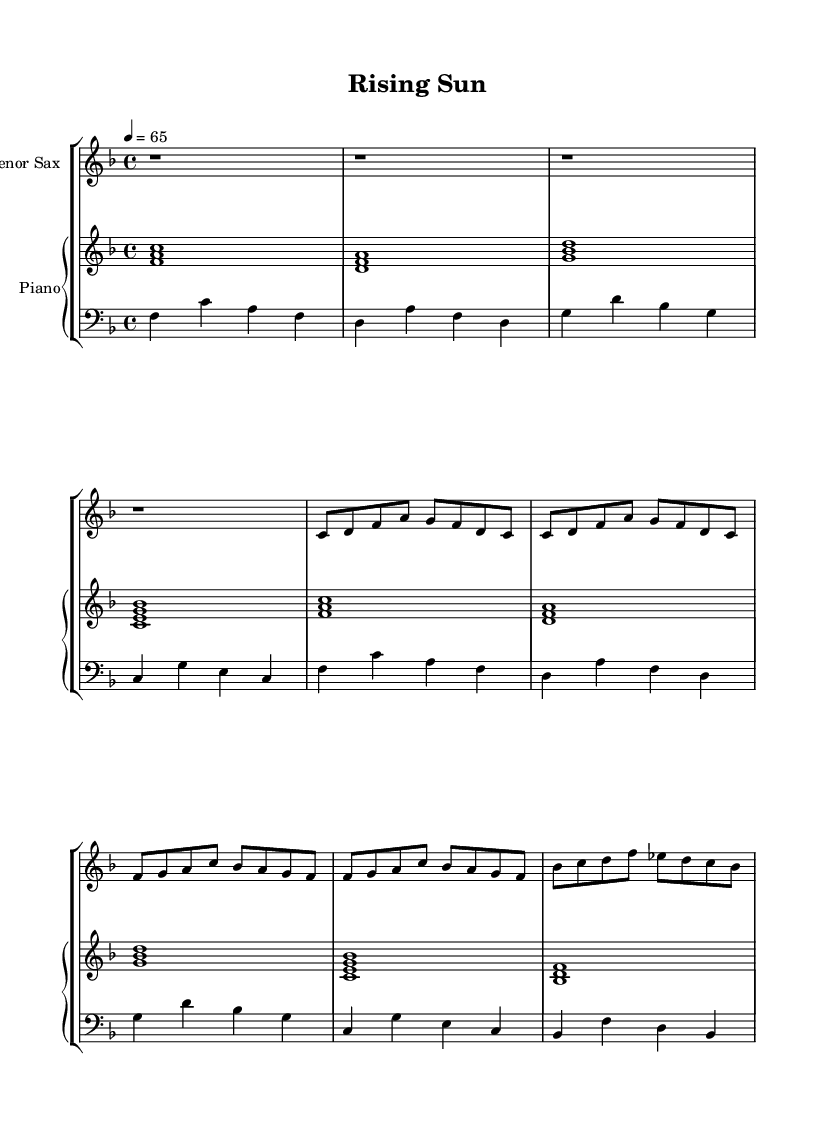What is the key signature of this music? The key signature is F major, which has one flat (B♭). You can identify the key signature by looking at the sharp or flat symbols placed at the beginning of the staff. In this piece, there is one flat, indicating F major.
Answer: F major What is the time signature of this piece? The time signature is 4/4, which is represented as a fraction at the beginning of the staff. The top number indicates that there are four beats in each measure, and the bottom number indicates that the quarter note gets one beat.
Answer: 4/4 What is the tempo marking for this music? The tempo marking is 4 equals 65, meaning that there are 65 beats per minute. This marking is shown above the staff. The number indicates the speed at which the piece should be played, and the use of quarter note (4) means that each beat in a 4/4 measure is counted as a quarter note.
Answer: 65 How many measures are in the saxophone melody? The saxophone melody consists of 8 measures. You can count the measures by looking for the vertical lines that separate the music into sections; each section is called a measure. The saxophone part has 8 such sections.
Answer: 8 What type of music is represented in this score? This score represents smooth jazz ballads, characterized by laid-back rhythms and a focus on melodic expression. The style is evident in the melodic phrases and harmonic choices found in both the saxophone and piano parts.
Answer: Smooth jazz ballad What role does the left hand of the piano play in this piece? The left hand of the piano plays supporting harmonies and bass notes, providing a foundation over which the melody is played. You can identify this by looking at the bass clef staff, where the left-hand notes are notated, generally outlining the chords and providing rhythmic support.
Answer: Supporting harmonies 